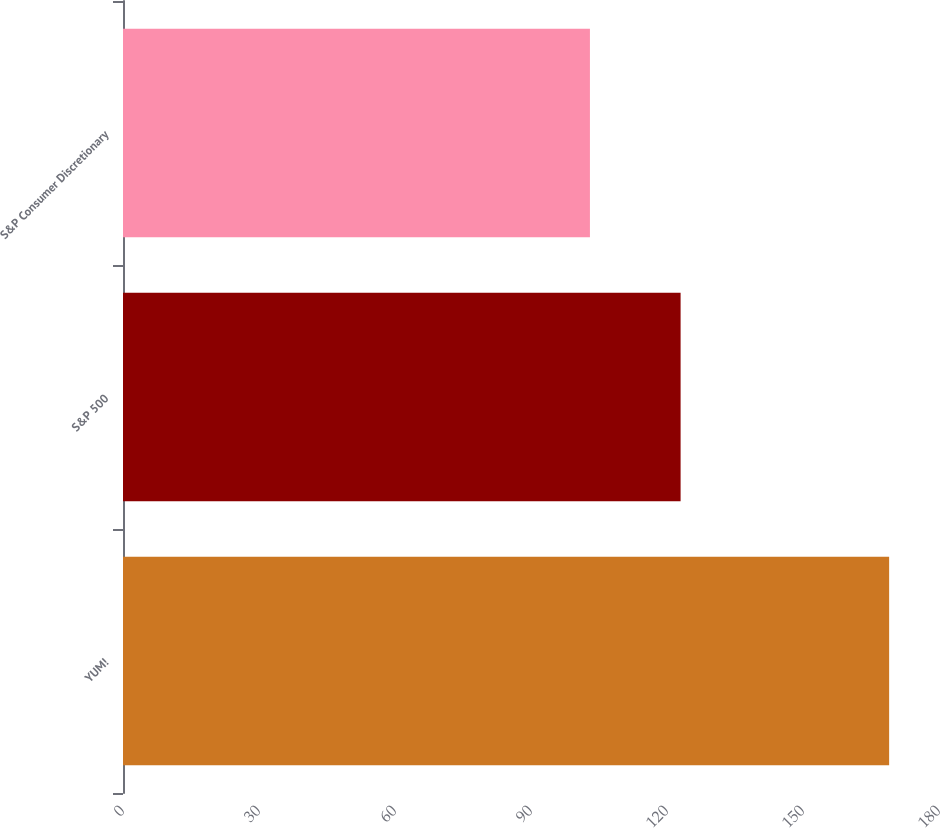Convert chart. <chart><loc_0><loc_0><loc_500><loc_500><bar_chart><fcel>YUM!<fcel>S&P 500<fcel>S&P Consumer Discretionary<nl><fcel>169<fcel>123<fcel>103<nl></chart> 